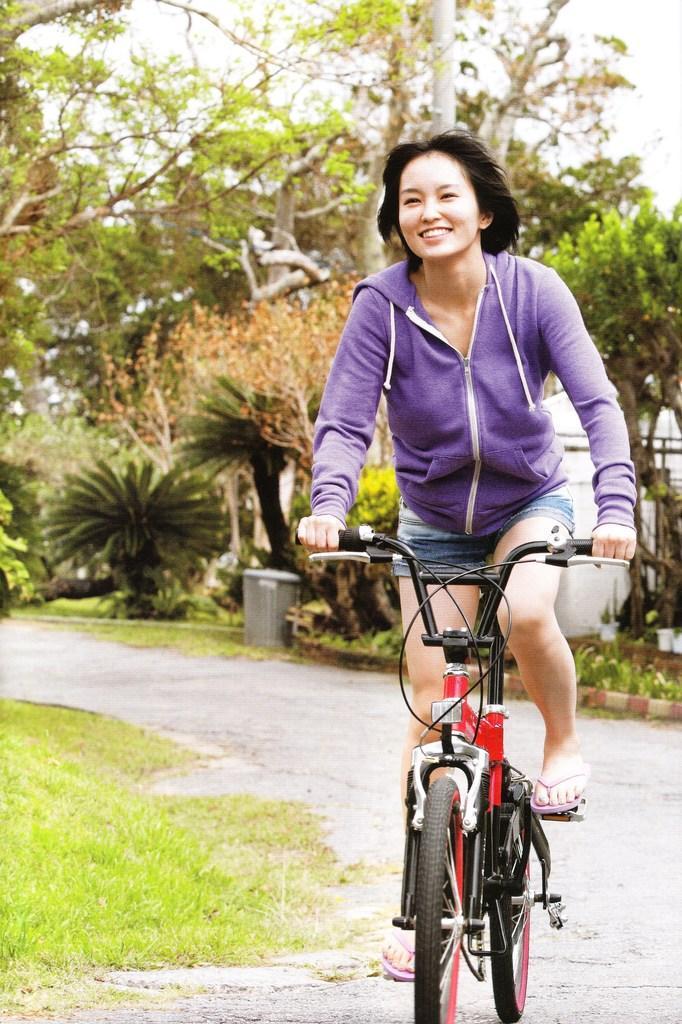Describe this image in one or two sentences. This picture shows a woman riding a bicycle and we see few trees and plants on a back 